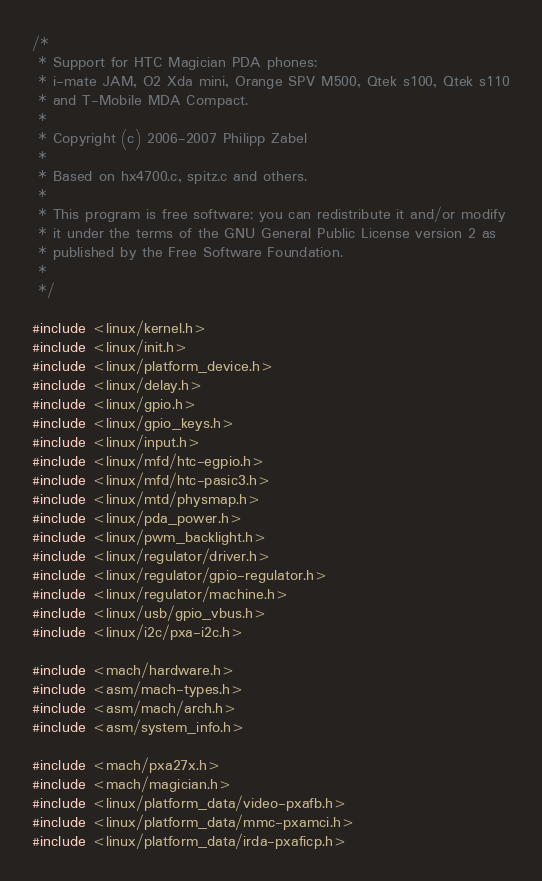<code> <loc_0><loc_0><loc_500><loc_500><_C_>/*
 * Support for HTC Magician PDA phones:
 * i-mate JAM, O2 Xda mini, Orange SPV M500, Qtek s100, Qtek s110
 * and T-Mobile MDA Compact.
 *
 * Copyright (c) 2006-2007 Philipp Zabel
 *
 * Based on hx4700.c, spitz.c and others.
 *
 * This program is free software; you can redistribute it and/or modify
 * it under the terms of the GNU General Public License version 2 as
 * published by the Free Software Foundation.
 *
 */

#include <linux/kernel.h>
#include <linux/init.h>
#include <linux/platform_device.h>
#include <linux/delay.h>
#include <linux/gpio.h>
#include <linux/gpio_keys.h>
#include <linux/input.h>
#include <linux/mfd/htc-egpio.h>
#include <linux/mfd/htc-pasic3.h>
#include <linux/mtd/physmap.h>
#include <linux/pda_power.h>
#include <linux/pwm_backlight.h>
#include <linux/regulator/driver.h>
#include <linux/regulator/gpio-regulator.h>
#include <linux/regulator/machine.h>
#include <linux/usb/gpio_vbus.h>
#include <linux/i2c/pxa-i2c.h>

#include <mach/hardware.h>
#include <asm/mach-types.h>
#include <asm/mach/arch.h>
#include <asm/system_info.h>

#include <mach/pxa27x.h>
#include <mach/magician.h>
#include <linux/platform_data/video-pxafb.h>
#include <linux/platform_data/mmc-pxamci.h>
#include <linux/platform_data/irda-pxaficp.h></code> 